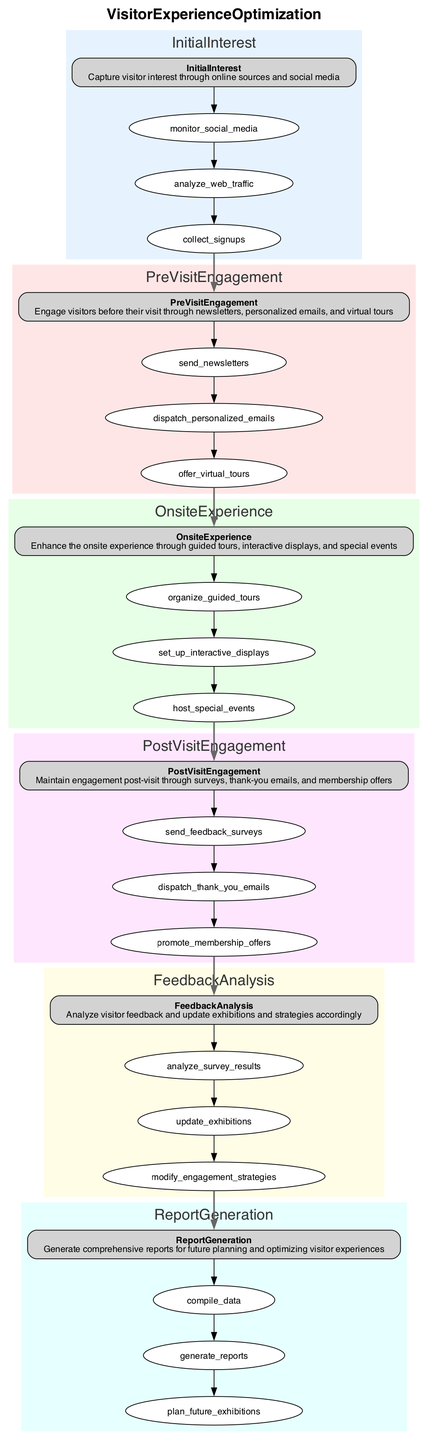What is the first stage of the Visitor Experience Optimization function? The first stage is labeled "InitialInterest," which is obtained by reading the diagram where the nodes represent each stage in the function.
Answer: InitialInterest How many actions are there in the "OnsiteExperience" stage? "OnsiteExperience" has three actions as indicated by the respective nodes connected to it in the diagram.
Answer: 3 What action is performed in the "PreVisitEngagement" stage? One of the actions in this stage is "send_newsletters," which is highlighted under the corresponding node.
Answer: send_newsletters What connects the "InitialInterest" stage to the "PreVisitEngagement" stage? The connection is made through a bold edge that links the last action in "InitialInterest" to the first action in "PreVisitEngagement," indicating the flow of the visitor experience.
Answer: bold edge Which stage involves analyzing survey results? The "FeedbackAnalysis" stage is responsible for analyzing survey results, as evident from the node labeled with that action in the diagram.
Answer: FeedbackAnalysis What is the last action listed in the "PostVisitEngagement" stage? The last action is "promote_membership_offers," which appears last in the sequence of actions under that stage in the diagram.
Answer: promote_membership_offers How many stages are there in total in the Visitor Experience Optimization function? There are six stages, which can be counted by reviewing each unique node representing the stages in the diagram.
Answer: 6 Which stage comes after "OnsiteExperience"? The stage that follows "OnsiteExperience" is "PostVisitEngagement," as indicated by the flow of connections in the diagram.
Answer: PostVisitEngagement What is the function name of this flowchart? The function is named "VisitorExperienceOptimization," clearly stated at the top of the diagram.
Answer: VisitorExperienceOptimization 